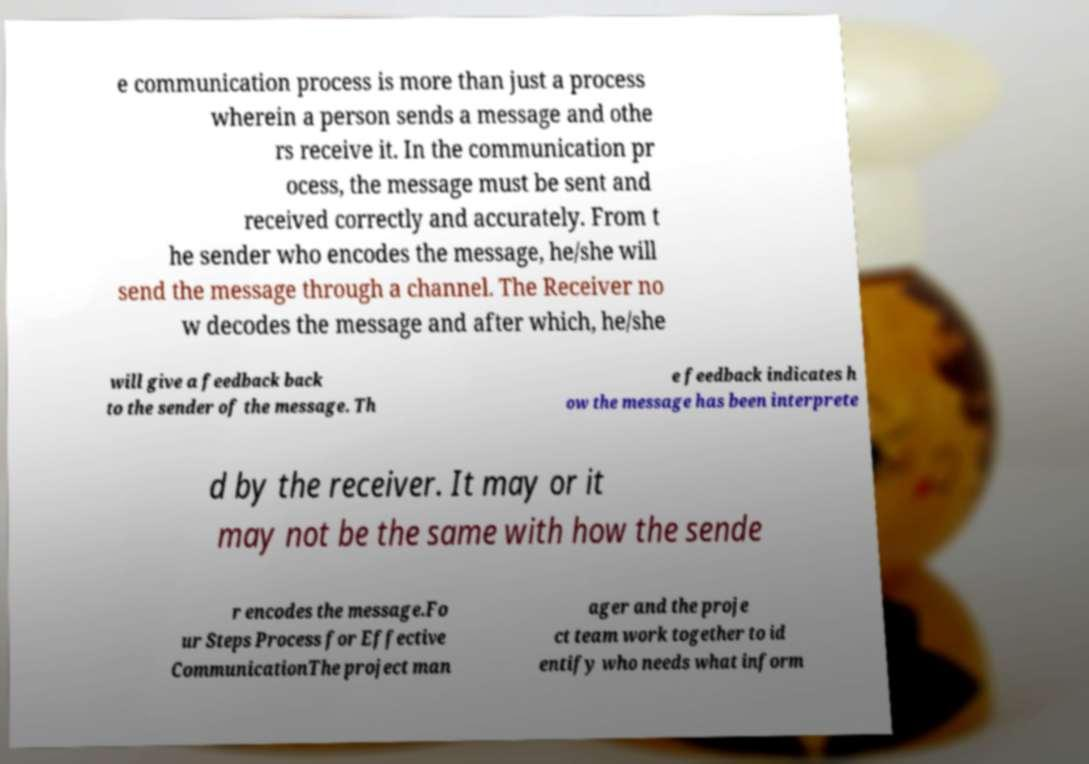Could you assist in decoding the text presented in this image and type it out clearly? e communication process is more than just a process wherein a person sends a message and othe rs receive it. In the communication pr ocess, the message must be sent and received correctly and accurately. From t he sender who encodes the message, he/she will send the message through a channel. The Receiver no w decodes the message and after which, he/she will give a feedback back to the sender of the message. Th e feedback indicates h ow the message has been interprete d by the receiver. It may or it may not be the same with how the sende r encodes the message.Fo ur Steps Process for Effective CommunicationThe project man ager and the proje ct team work together to id entify who needs what inform 